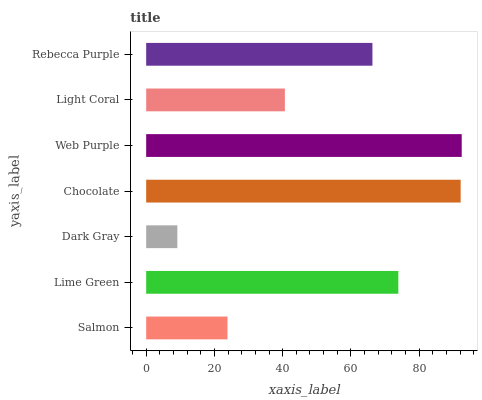Is Dark Gray the minimum?
Answer yes or no. Yes. Is Web Purple the maximum?
Answer yes or no. Yes. Is Lime Green the minimum?
Answer yes or no. No. Is Lime Green the maximum?
Answer yes or no. No. Is Lime Green greater than Salmon?
Answer yes or no. Yes. Is Salmon less than Lime Green?
Answer yes or no. Yes. Is Salmon greater than Lime Green?
Answer yes or no. No. Is Lime Green less than Salmon?
Answer yes or no. No. Is Rebecca Purple the high median?
Answer yes or no. Yes. Is Rebecca Purple the low median?
Answer yes or no. Yes. Is Dark Gray the high median?
Answer yes or no. No. Is Web Purple the low median?
Answer yes or no. No. 